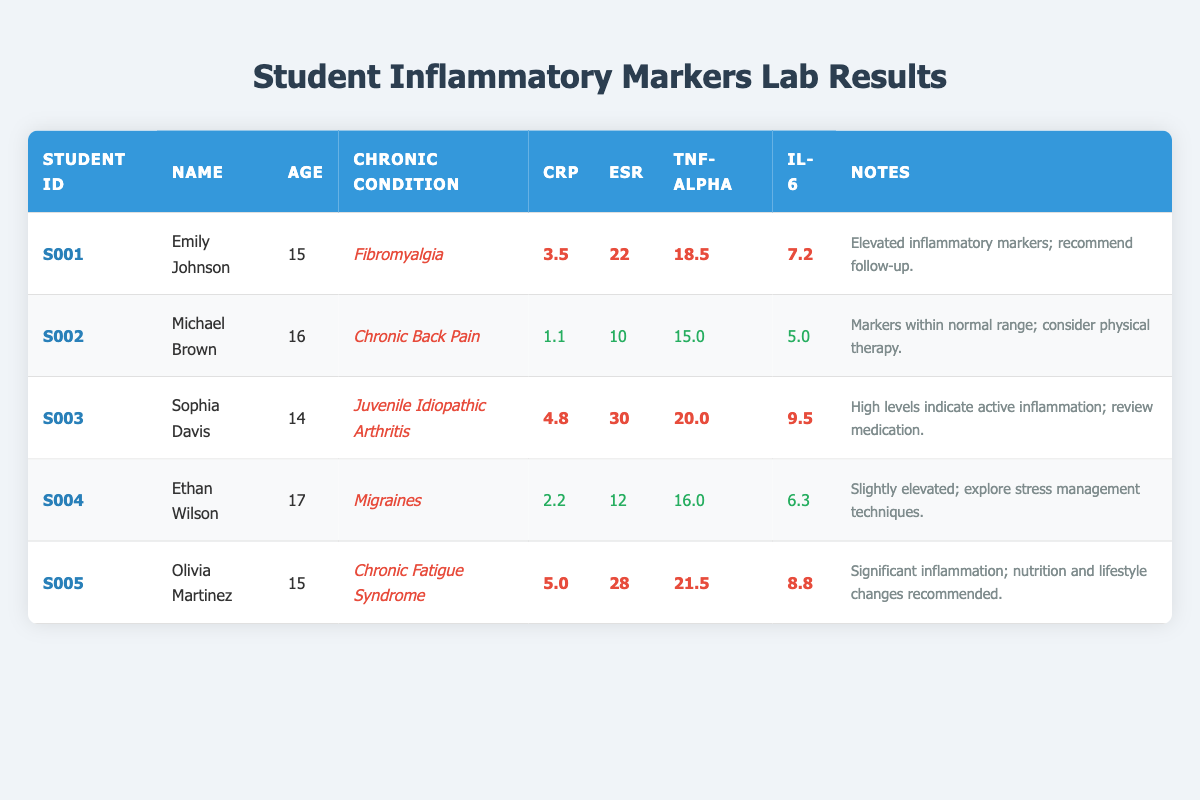What is the CRP value for Sophia Davis? The CRP value for Sophia Davis is listed in the table under her row. Referring to her data, the CRP is 4.8.
Answer: 4.8 Which student has the highest TNF-alpha level? By comparing the TNF-alpha values in the table, Olivia Martinez has the highest TNF-alpha level of 21.5.
Answer: Olivia Martinez Is Michael Brown's inflammation marker profile within normal range? By looking at Michael Brown's row, all his inflammatory markers (CRP: 1.1, ESR: 10, TNF-alpha: 15.0, IL-6: 5.0) are marked as normal according to the notes.
Answer: Yes What is the average IL-6 level for students with elevated inflammatory markers? First, identify which students have elevated levels: Emily Johnson (7.2), Sophia Davis (9.5), Olivia Martinez (8.8). Then, calculate the average: (7.2 + 9.5 + 8.8) = 25.5; there are 3 students, so the average is 25.5 / 3 = 8.5.
Answer: 8.5 Does Ethan Wilson have any elevated inflammatory markers? Looking at Ethan Wilson's results, his CRP, ESR, TNF-alpha, and IL-6 values (2.2, 12, 16.0, 6.3) are all in the normal range, as noted.
Answer: No Which chronic condition corresponds to the highest ESR value? From the table, Sophia Davis has the highest ESR value of 30, which corresponds to Juvenile Idiopathic Arthritis.
Answer: Juvenile Idiopathic Arthritis What is the total number of students listed in the table? Counting the number of rows under the headers in the table reveals that there are 5 students in total.
Answer: 5 What recommendation is made for Olivia Martinez based on her lab results? Referencing the notes for Olivia Martinez, the recommendation is to consider nutrition and lifestyle changes due to significant inflammation.
Answer: Nutrition and lifestyle changes recommended 